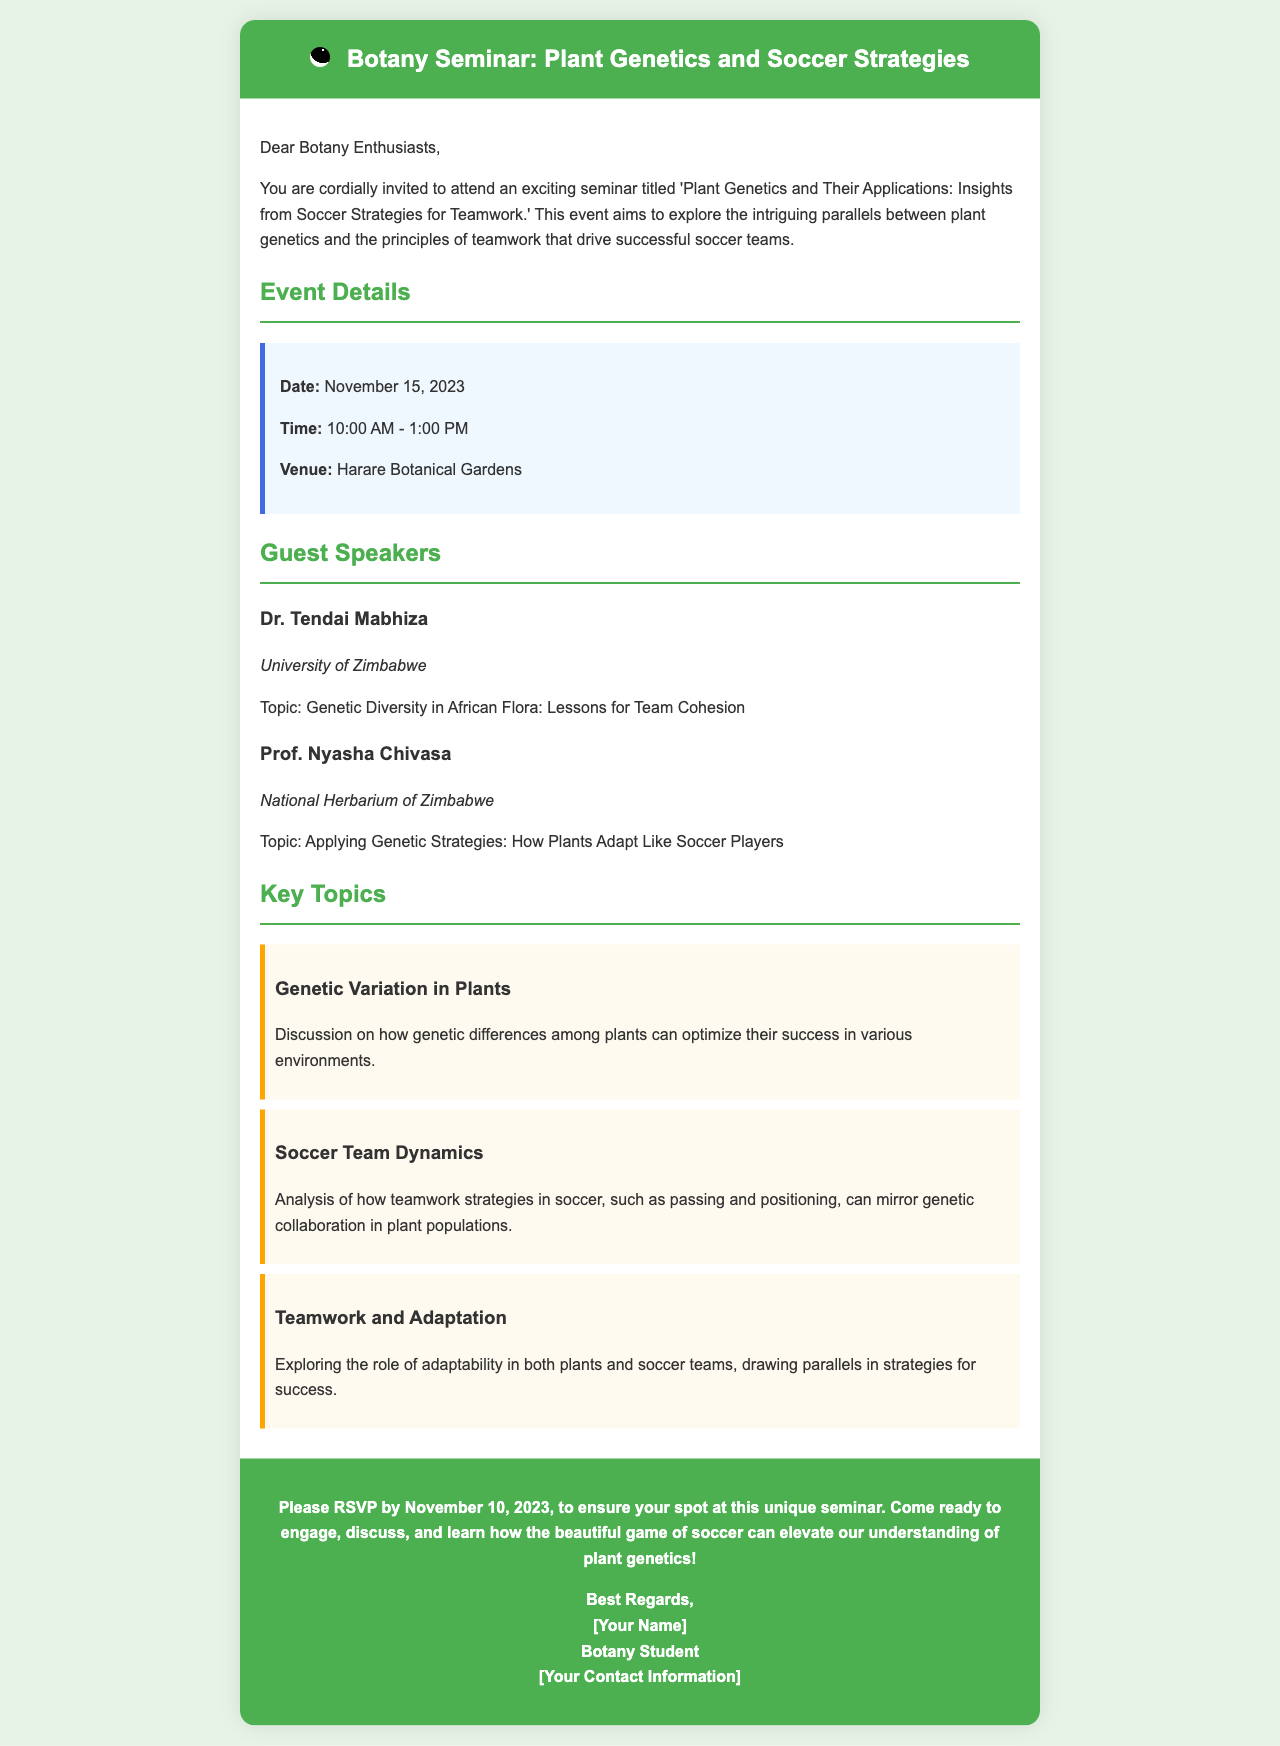What is the date of the seminar? The date of the seminar is explicitly stated in the event details section of the document.
Answer: November 15, 2023 Who is the first guest speaker? The first guest speaker, along with their title and institution, is listed under the guest speakers section.
Answer: Dr. Tendai Mabhiza What is the venue of the seminar? The venue is clearly mentioned in the event details section of the document.
Answer: Harare Botanical Gardens What topic does Prof. Nyasha Chivasa cover? The document provides specific topics for each guest speaker, including that of Prof. Nyasha Chivasa.
Answer: Applying Genetic Strategies: How Plants Adapt Like Soccer Players How long will the seminar last? The seminar time frame is indicated in the event details and can be calculated from the start and end times provided.
Answer: 3 hours What is the RSVP deadline for the seminar? The RSVP deadline is specified in the call-to-action section of the document.
Answer: November 10, 2023 What topic discusses the relationship between plant genetic diversity and teamwork? The document outlines key topics including a link between genetic diversity and teamwork principles.
Answer: Genetic Diversity in African Flora: Lessons for Team Cohesion Which two subjects are compared in the seminar's theme? The overarching theme of the seminar compares two distinct subjects, as indicated in the title and introductory paragraph.
Answer: Plant genetics and soccer strategies 